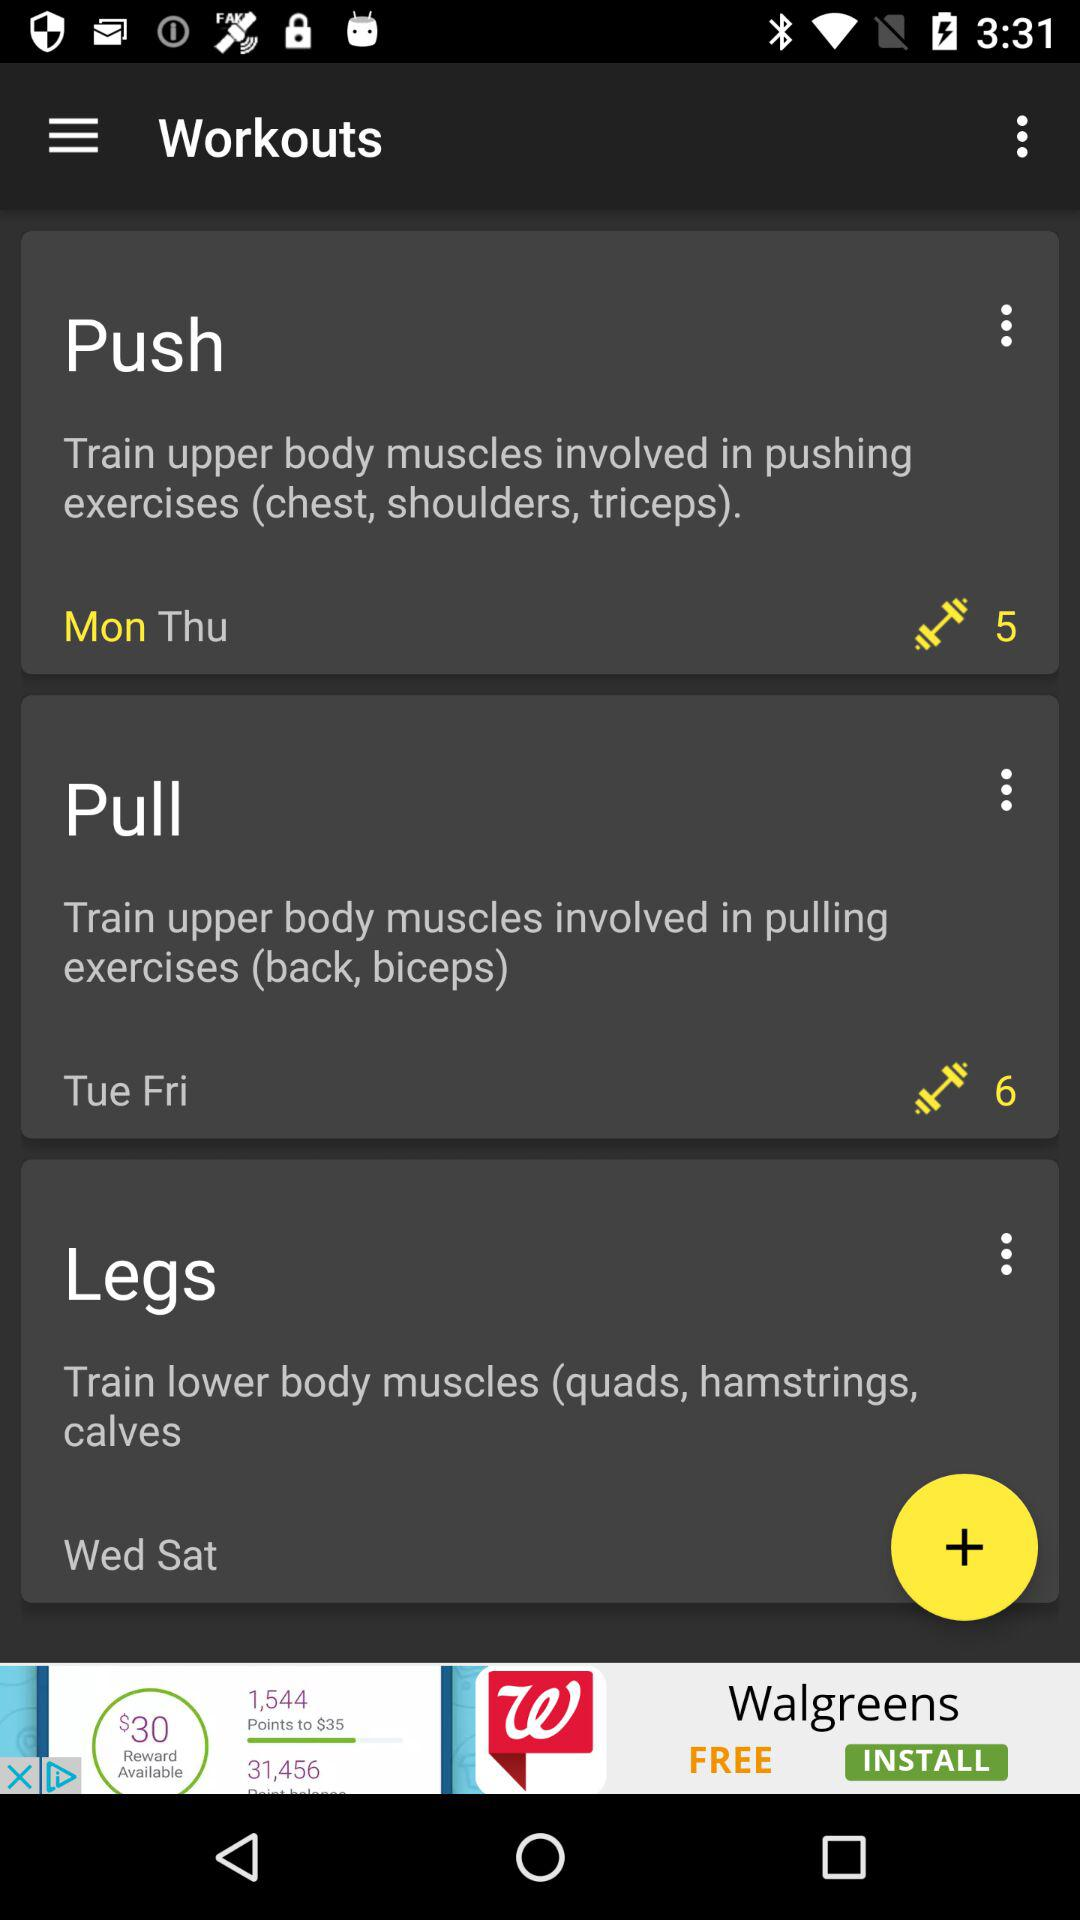Which days are for chest and shoulder workouts? The days for chest and shoulder workouts are Monday and Thursday. 